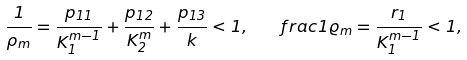Convert formula to latex. <formula><loc_0><loc_0><loc_500><loc_500>\frac { 1 } { \rho _ { m } } = \frac { p _ { 1 1 } } { K _ { 1 } ^ { m - 1 } } + \frac { p _ { 1 2 } } { K _ { 2 } ^ { m } } + \frac { p _ { 1 3 } } { k } < 1 , \ \ \ f r a c { 1 } { \varrho _ { m } } = \frac { r _ { 1 } } { K _ { 1 } ^ { m - 1 } } < 1 ,</formula> 